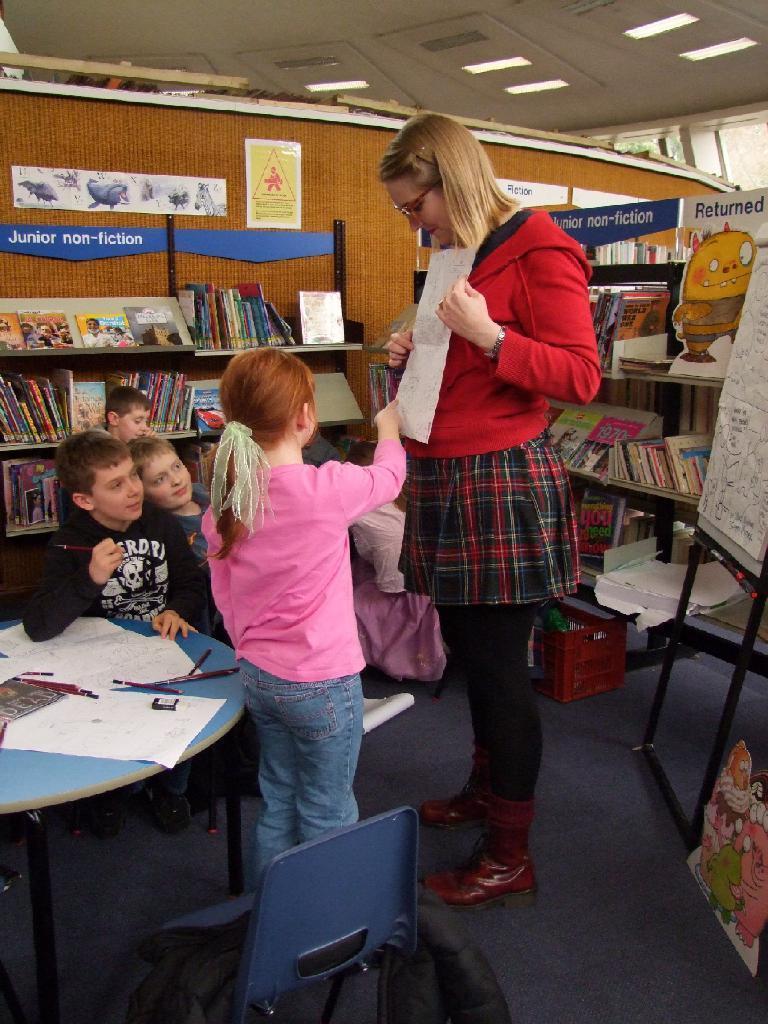Can you describe this image briefly? In this image we can see this child and lady standing. We can see children sitting near table. In the background we can see books on shelf, wall and board. 